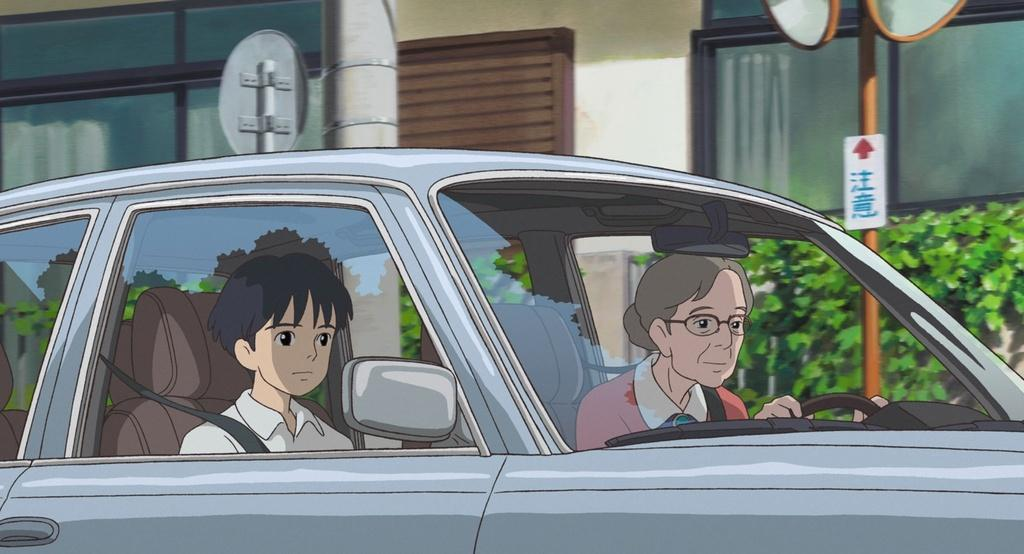What is the main subject of the image? There is a vehicle in the image. Are there any people present in the image? Yes, there are people in the image. What other objects can be seen in the image? There are poles, a board, bushes, and a building in the image. Can you describe the board in the image? There is a board in the image, and there is writing on it. What type of cub is playing with wool in the image? There is no cub or wool present in the image. How is the wax being used in the image? There is no wax present in the image. 